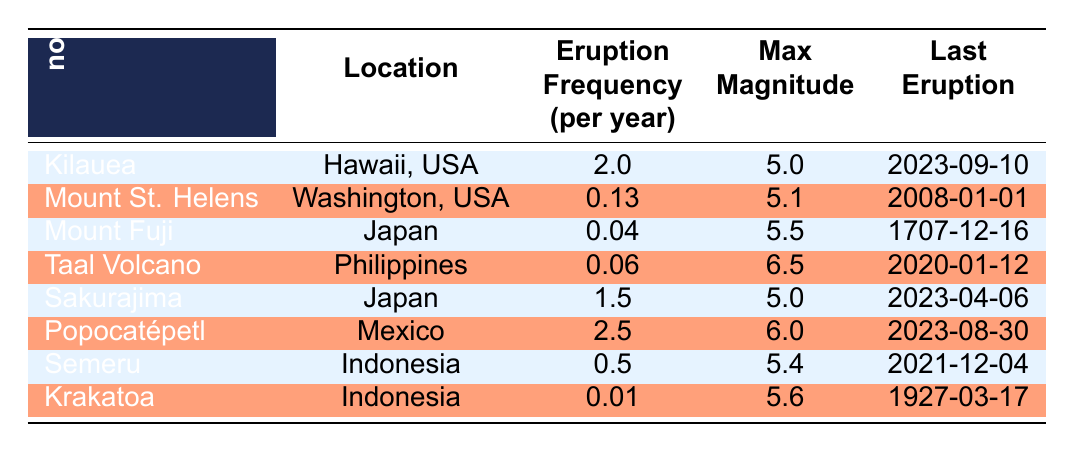What is the highest eruption frequency among the listed volcanoes? From the table, we can see that the highest eruption frequency is 2.5 eruptions per year for Popocatépetl, as compared to other listed volcanoes.
Answer: 2.5 Which volcano had the last eruption most recently? By referring to the last eruption dates in the table, Kilauea had its last eruption on 2023-09-10, which is the most recent date compared to others.
Answer: Kilauea What is the average maximum magnitude of eruptions for the volcanoes listed in the table? To find the average, we first sum all the maximum magnitudes: (5.0 + 5.1 + 5.5 + 6.5 + 5.0 + 6.0 + 5.4 + 5.6) = 44.2. Then, divide by the number of volcanoes (8): 44.2 / 8 = 5.525.
Answer: 5.525 Is it true that Taal Volcano has a higher eruption frequency than Mount Fuji? Checking the eruption frequencies from the table, Taal Volcano has a frequency of 0.06, while Mount Fuji has a frequency of 0.04. Since 0.06 is greater than 0.04, the statement is true.
Answer: Yes How many more eruptions per year does Popocatépetl have compared to Mount St. Helens? We subtract the eruption frequencies: 2.5 (Popocatépetl) - 0.13 (Mount St. Helens) = 2.37. Therefore, Popocatépetl has 2.37 more eruptions per year than Mount St. Helens.
Answer: 2.37 Which volcano has the lowest eruption frequency and what is that frequency? Looking through the table, Krakatoa has the lowest eruption frequency at 0.01 eruptions per year, making it the volcano with the lowest frequency.
Answer: 0.01 What is the difference in maximum magnitudes between Taal Volcano and Semeru? To find the difference, we calculate 6.5 (Taal Volcano) - 5.4 (Semeru) = 1.1. Therefore, the difference in maximum magnitudes is 1.1.
Answer: 1.1 Are there any volcanoes with a maximum magnitude of at least 6.0? By inspecting the table, both Taal Volcano (6.5) and Popocatépetl (6.0) have maximum magnitudes of at least 6.0, so the answer is yes.
Answer: Yes 